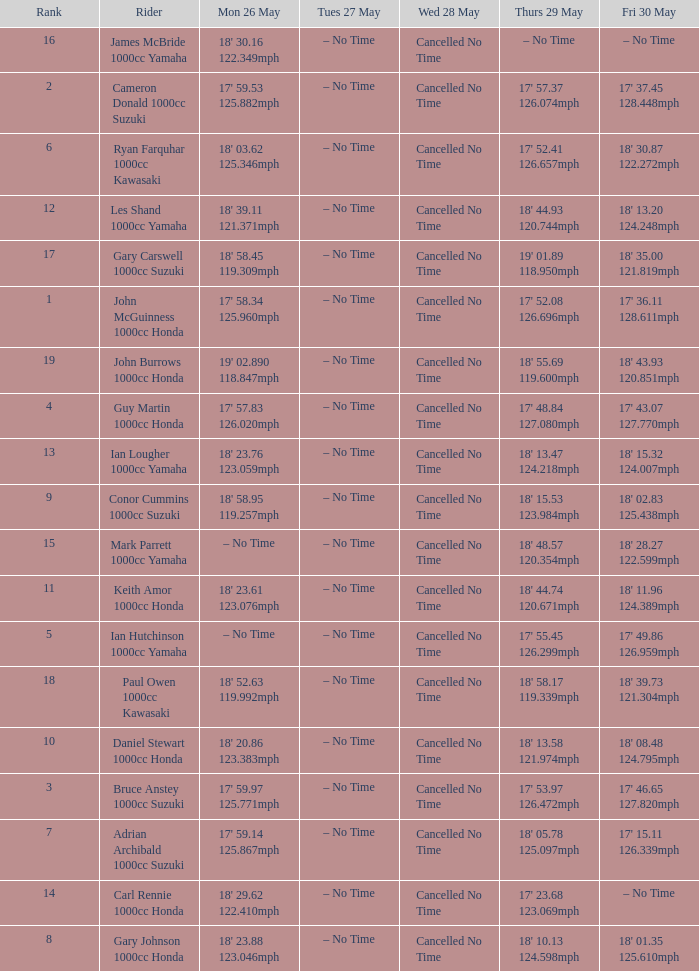What tims is wed may 28 and mon may 26 is 17' 58.34 125.960mph? Cancelled No Time. 